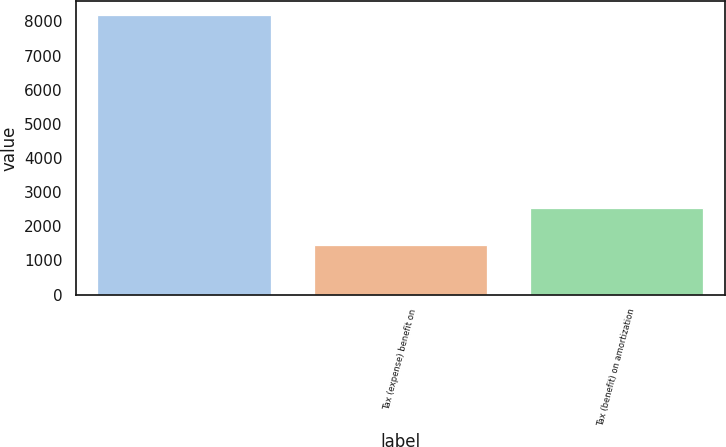<chart> <loc_0><loc_0><loc_500><loc_500><bar_chart><ecel><fcel>Tax (expense) benefit on<fcel>Tax (benefit) on amortization<nl><fcel>8180<fcel>1446.6<fcel>2529.2<nl></chart> 